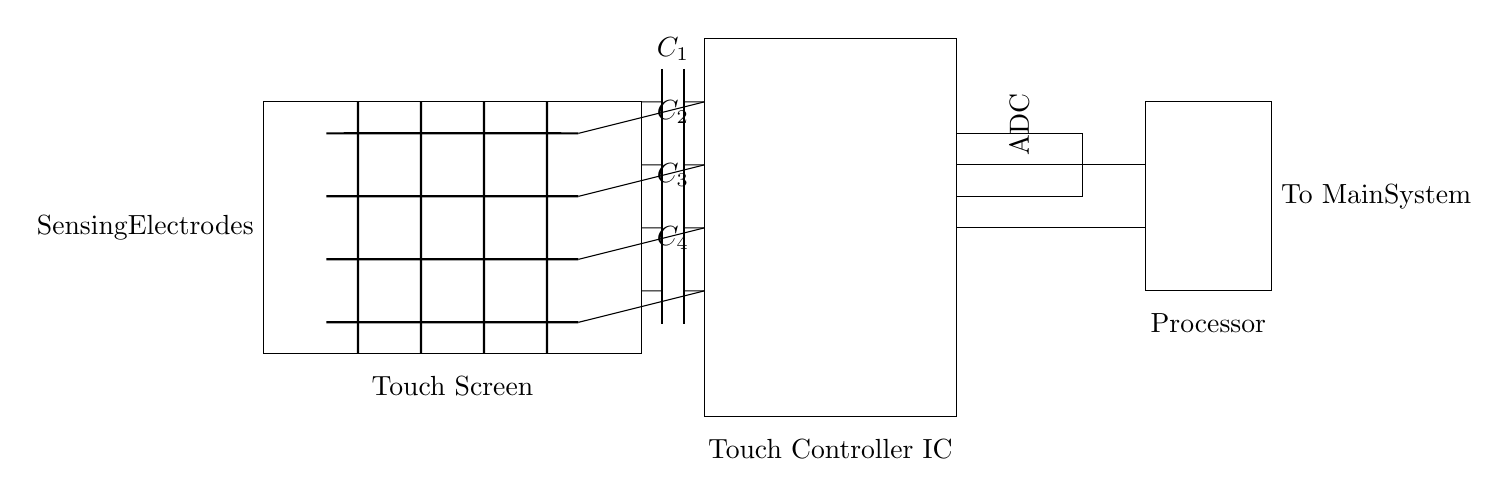What components are used in the circuit? The circuit includes sensing electrodes, capacitors, a touch controller IC, an ADC, and a processor. These components work together to detect user input on the touchscreen.
Answer: Sensing electrodes, capacitors, touch controller IC, ADC, processor How many sensing electrodes are present? There are four horizontal sensing electrodes shown in the diagram, as indicated by the thick lines at specific vertical positions.
Answer: Four What function does the ADC perform in this circuit? The ADC, or Analog-to-Digital Converter, converts the analog signals detected by the sensing electrodes into digital signals that the processor can process. This is essential for translating touch inputs into usable data.
Answer: Converts analog signals to digital Which component is directly connected to the touch screen on the right side? The touch controller IC is connected to the touch screen, serving as the interface between the touch screen and the processing components.
Answer: Touch controller IC Why are there capacitors in this circuit? The capacitors play a role in filtering and stabilizing the signals from the sensing electrodes, ensuring accurate detection of touch events. They help manage the charge and discharge related to touch inputs.
Answer: For filtering and stabilization What is the significant role of the processor in the circuit? The processor handles the data received from the ADC after the touch controller processes the signals from the touch screen. It interprets the user input and manages responses accordingly.
Answer: Processes user input signals 